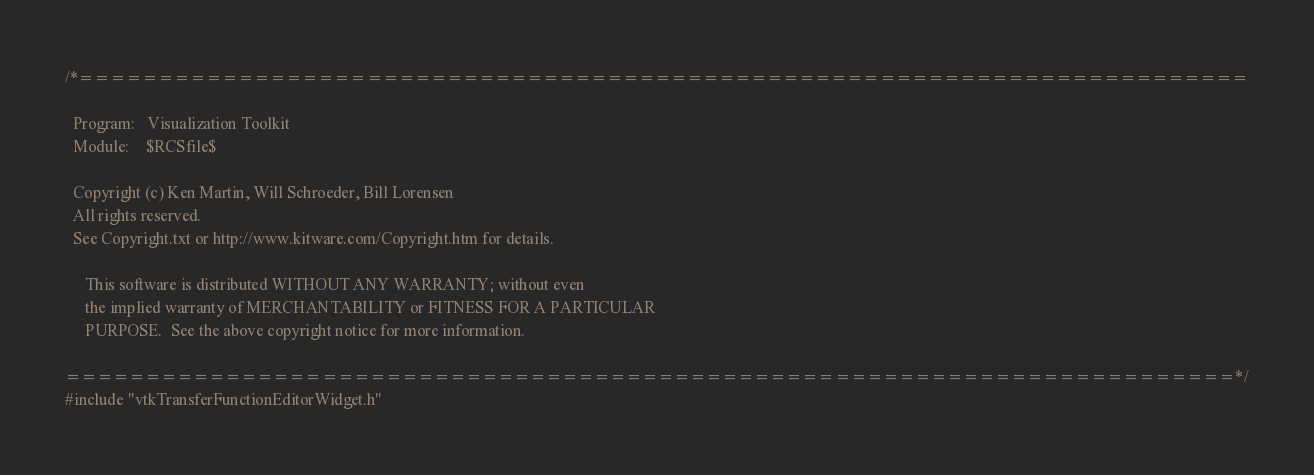<code> <loc_0><loc_0><loc_500><loc_500><_C++_>/*=========================================================================

  Program:   Visualization Toolkit
  Module:    $RCSfile$

  Copyright (c) Ken Martin, Will Schroeder, Bill Lorensen
  All rights reserved.
  See Copyright.txt or http://www.kitware.com/Copyright.htm for details.

     This software is distributed WITHOUT ANY WARRANTY; without even
     the implied warranty of MERCHANTABILITY or FITNESS FOR A PARTICULAR
     PURPOSE.  See the above copyright notice for more information.

=========================================================================*/
#include "vtkTransferFunctionEditorWidget.h"
</code> 